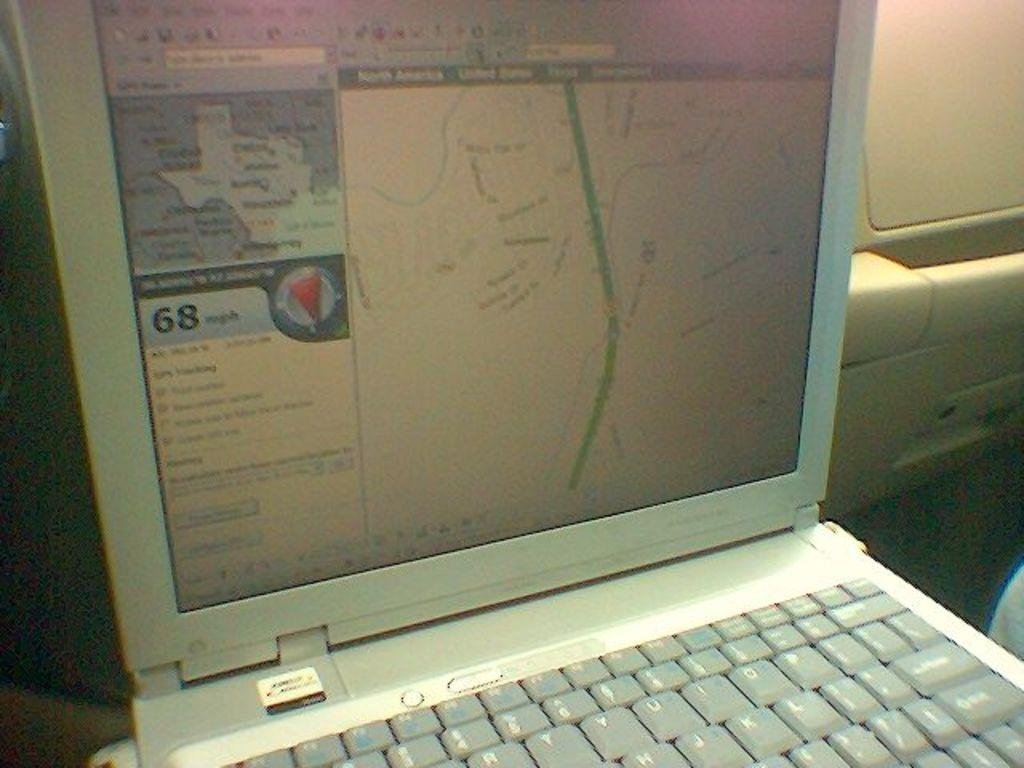<image>
Present a compact description of the photo's key features. The laptop shows that the wind is 68 mph and is going south. 